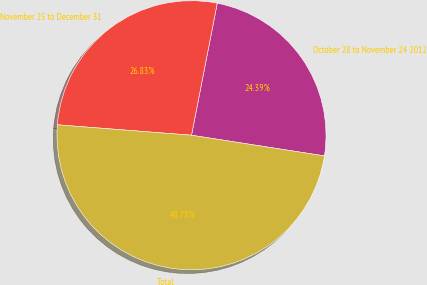<chart> <loc_0><loc_0><loc_500><loc_500><pie_chart><fcel>October 28 to November 24 2012<fcel>November 25 to December 31<fcel>Total<nl><fcel>24.39%<fcel>26.83%<fcel>48.78%<nl></chart> 